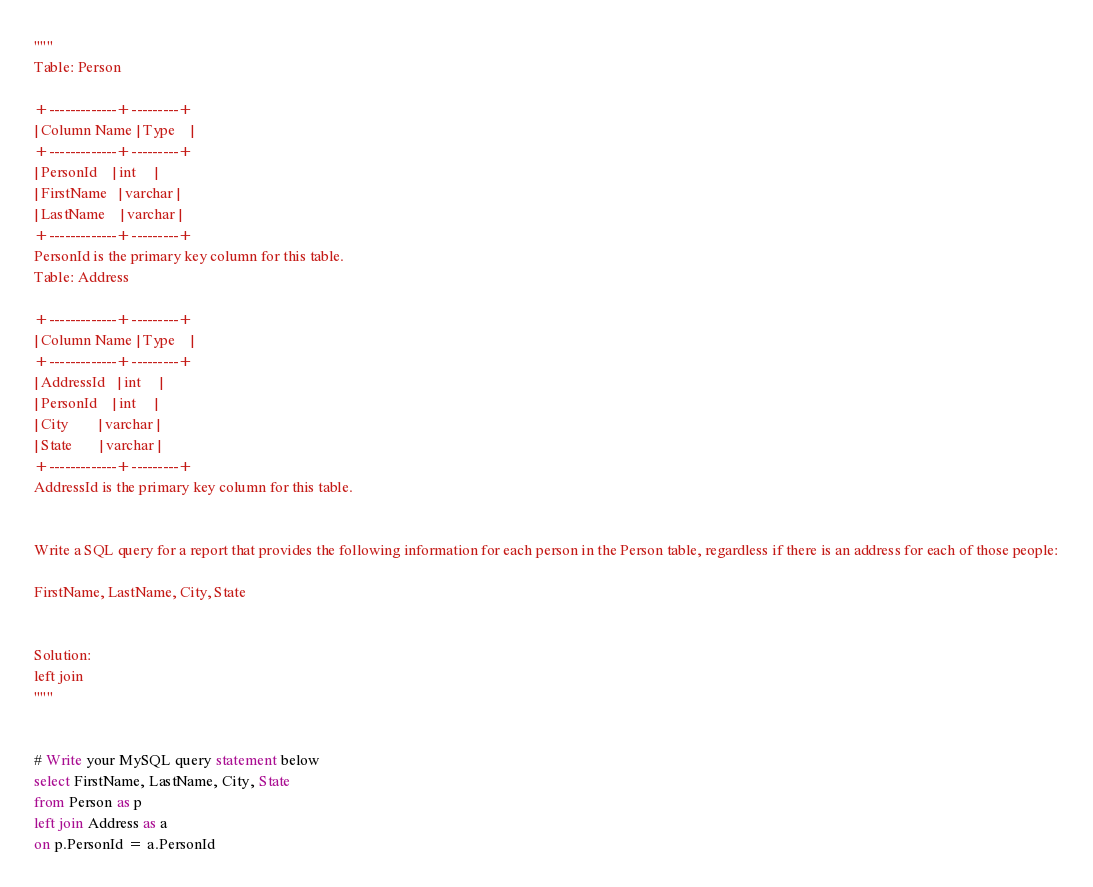<code> <loc_0><loc_0><loc_500><loc_500><_SQL_>"""
Table: Person

+-------------+---------+
| Column Name | Type    |
+-------------+---------+
| PersonId    | int     |
| FirstName   | varchar |
| LastName    | varchar |
+-------------+---------+
PersonId is the primary key column for this table.
Table: Address

+-------------+---------+
| Column Name | Type    |
+-------------+---------+
| AddressId   | int     |
| PersonId    | int     |
| City        | varchar |
| State       | varchar |
+-------------+---------+
AddressId is the primary key column for this table.
 

Write a SQL query for a report that provides the following information for each person in the Person table, regardless if there is an address for each of those people:

FirstName, LastName, City, State


Solution:
left join
"""


# Write your MySQL query statement below
select FirstName, LastName, City, State
from Person as p
left join Address as a
on p.PersonId = a.PersonId</code> 